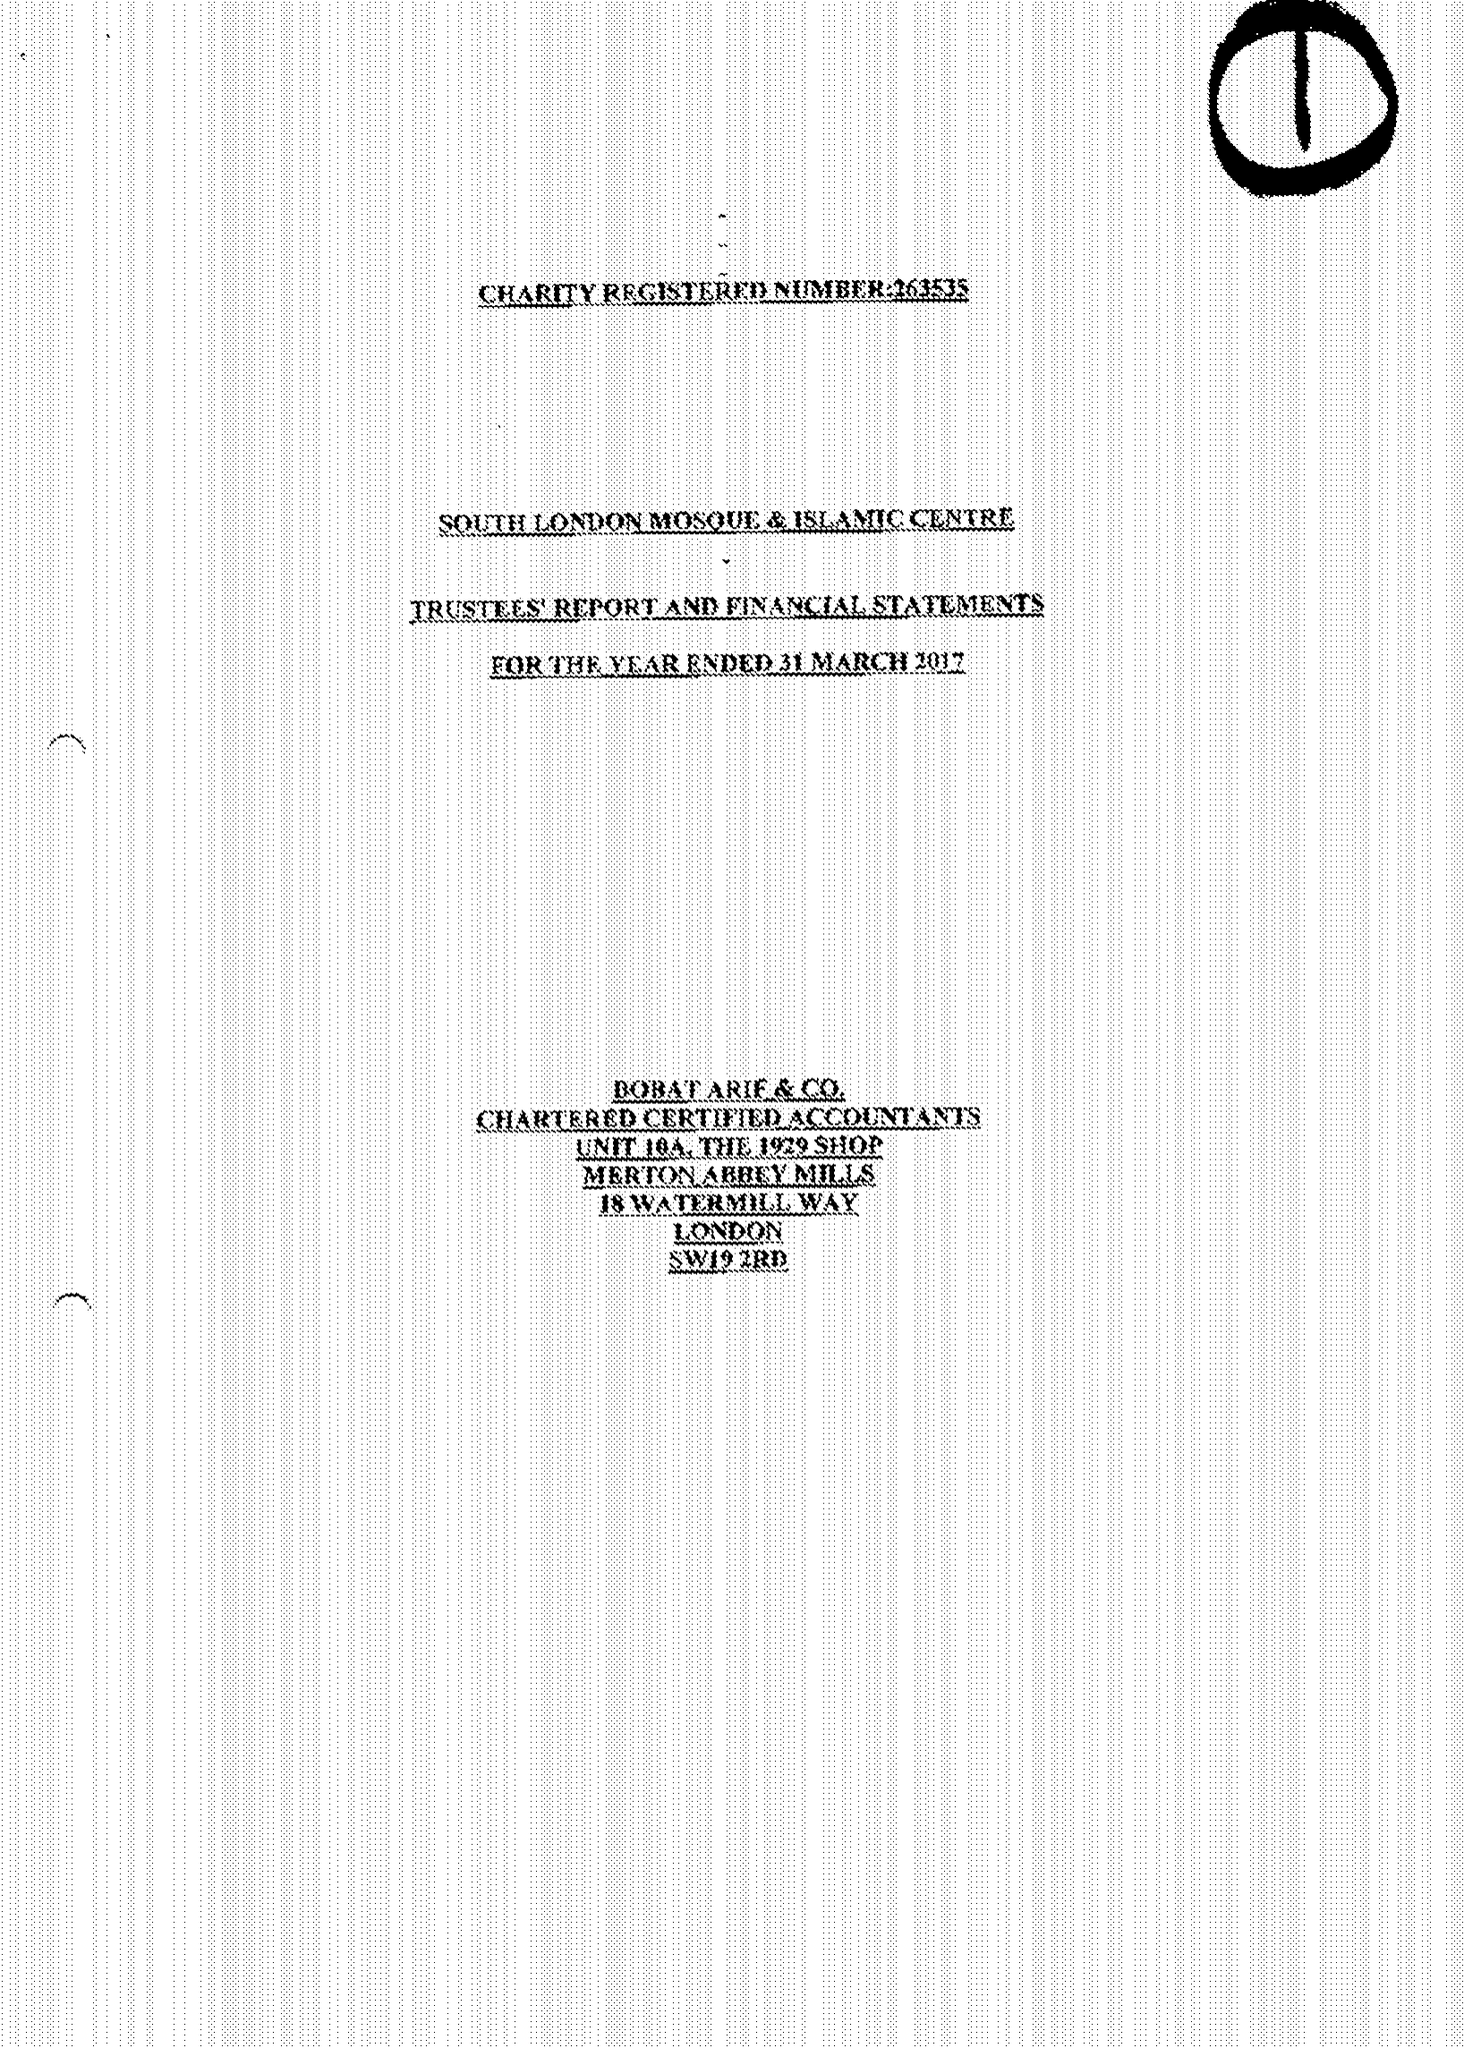What is the value for the address__street_line?
Answer the question using a single word or phrase. 8 MITCHAM LANE 